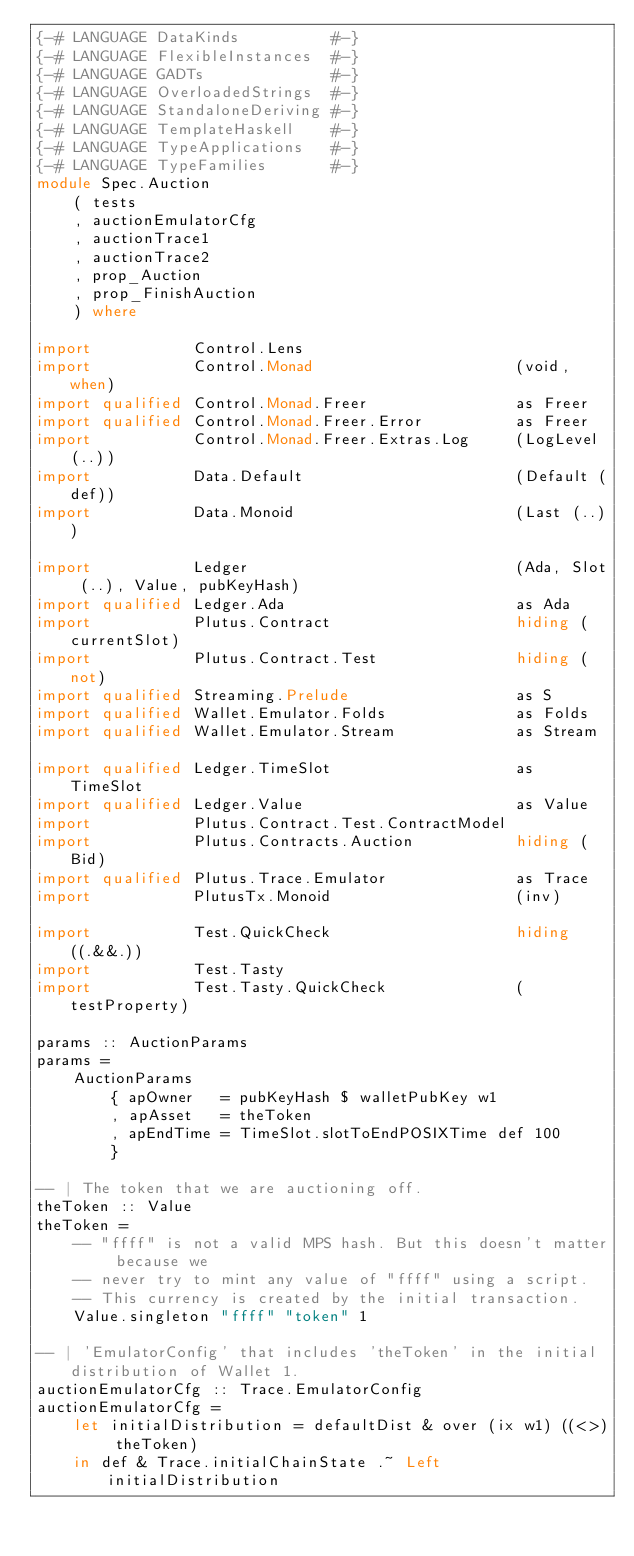Convert code to text. <code><loc_0><loc_0><loc_500><loc_500><_Haskell_>{-# LANGUAGE DataKinds          #-}
{-# LANGUAGE FlexibleInstances  #-}
{-# LANGUAGE GADTs              #-}
{-# LANGUAGE OverloadedStrings  #-}
{-# LANGUAGE StandaloneDeriving #-}
{-# LANGUAGE TemplateHaskell    #-}
{-# LANGUAGE TypeApplications   #-}
{-# LANGUAGE TypeFamilies       #-}
module Spec.Auction
    ( tests
    , auctionEmulatorCfg
    , auctionTrace1
    , auctionTrace2
    , prop_Auction
    , prop_FinishAuction
    ) where

import           Control.Lens
import           Control.Monad                      (void, when)
import qualified Control.Monad.Freer                as Freer
import qualified Control.Monad.Freer.Error          as Freer
import           Control.Monad.Freer.Extras.Log     (LogLevel (..))
import           Data.Default                       (Default (def))
import           Data.Monoid                        (Last (..))

import           Ledger                             (Ada, Slot (..), Value, pubKeyHash)
import qualified Ledger.Ada                         as Ada
import           Plutus.Contract                    hiding (currentSlot)
import           Plutus.Contract.Test               hiding (not)
import qualified Streaming.Prelude                  as S
import qualified Wallet.Emulator.Folds              as Folds
import qualified Wallet.Emulator.Stream             as Stream

import qualified Ledger.TimeSlot                    as TimeSlot
import qualified Ledger.Value                       as Value
import           Plutus.Contract.Test.ContractModel
import           Plutus.Contracts.Auction           hiding (Bid)
import qualified Plutus.Trace.Emulator              as Trace
import           PlutusTx.Monoid                    (inv)

import           Test.QuickCheck                    hiding ((.&&.))
import           Test.Tasty
import           Test.Tasty.QuickCheck              (testProperty)

params :: AuctionParams
params =
    AuctionParams
        { apOwner   = pubKeyHash $ walletPubKey w1
        , apAsset   = theToken
        , apEndTime = TimeSlot.slotToEndPOSIXTime def 100
        }

-- | The token that we are auctioning off.
theToken :: Value
theToken =
    -- "ffff" is not a valid MPS hash. But this doesn't matter because we
    -- never try to mint any value of "ffff" using a script.
    -- This currency is created by the initial transaction.
    Value.singleton "ffff" "token" 1

-- | 'EmulatorConfig' that includes 'theToken' in the initial distribution of Wallet 1.
auctionEmulatorCfg :: Trace.EmulatorConfig
auctionEmulatorCfg =
    let initialDistribution = defaultDist & over (ix w1) ((<>) theToken)
    in def & Trace.initialChainState .~ Left initialDistribution
</code> 